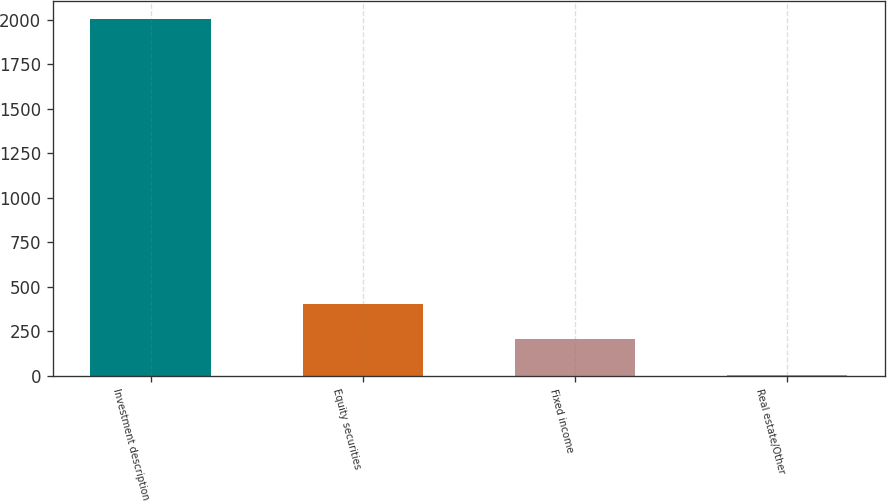Convert chart. <chart><loc_0><loc_0><loc_500><loc_500><bar_chart><fcel>Investment description<fcel>Equity securities<fcel>Fixed income<fcel>Real estate/Other<nl><fcel>2007<fcel>404.76<fcel>204.48<fcel>4.2<nl></chart> 